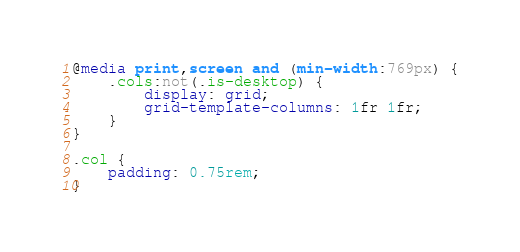Convert code to text. <code><loc_0><loc_0><loc_500><loc_500><_CSS_>@media print,screen and (min-width:769px) {
	.cols:not(.is-desktop) {
		display: grid;
		grid-template-columns: 1fr 1fr;
	}
}

.col {
	padding: 0.75rem;
}

</code> 